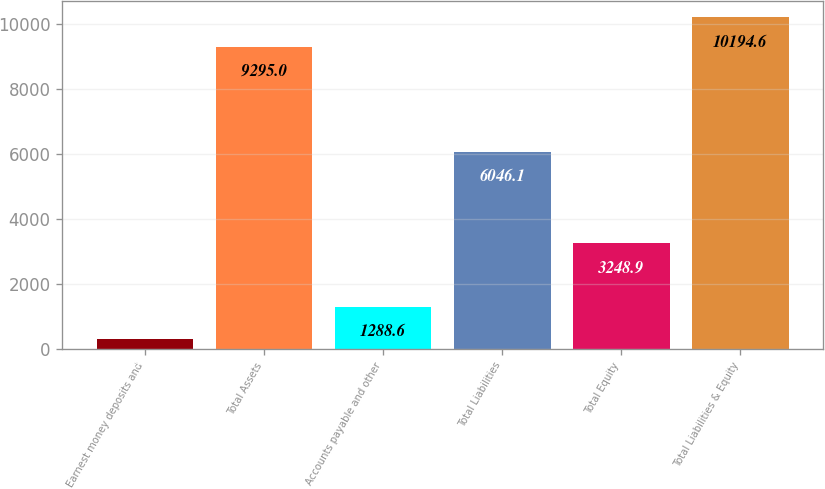Convert chart to OTSL. <chart><loc_0><loc_0><loc_500><loc_500><bar_chart><fcel>Earnest money deposits and<fcel>Total Assets<fcel>Accounts payable and other<fcel>Total Liabilities<fcel>Total Equity<fcel>Total Liabilities & Equity<nl><fcel>299<fcel>9295<fcel>1288.6<fcel>6046.1<fcel>3248.9<fcel>10194.6<nl></chart> 